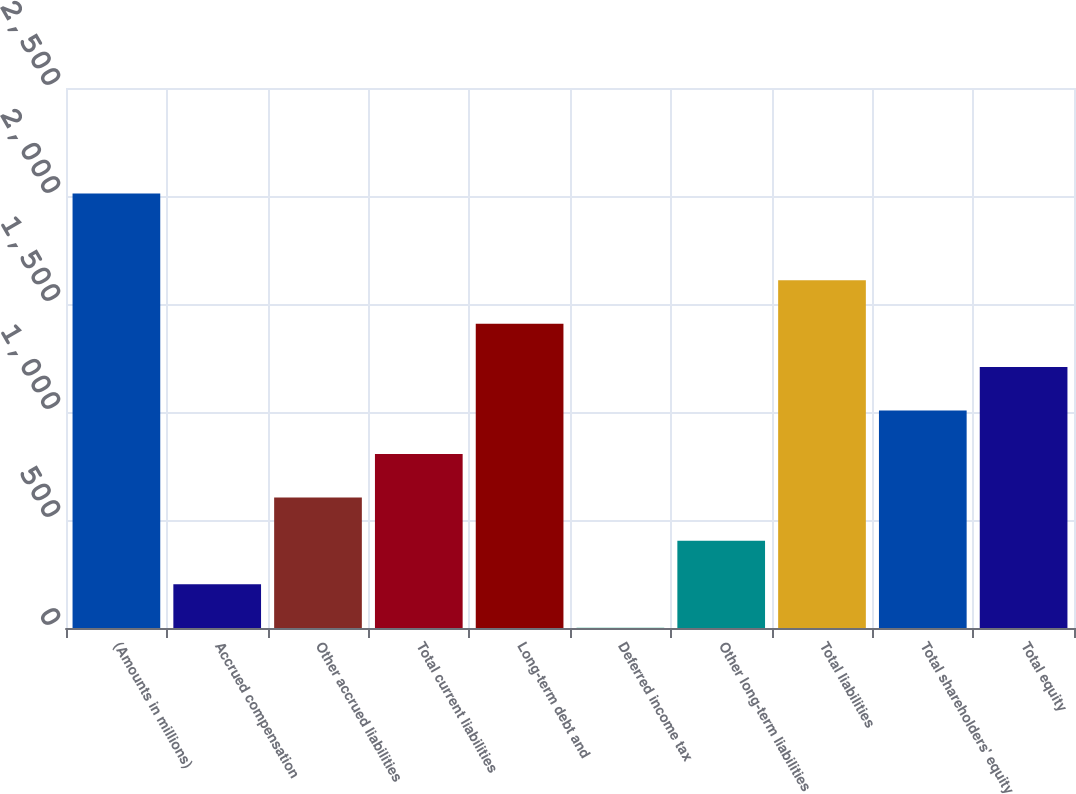Convert chart to OTSL. <chart><loc_0><loc_0><loc_500><loc_500><bar_chart><fcel>(Amounts in millions)<fcel>Accrued compensation<fcel>Other accrued liabilities<fcel>Total current liabilities<fcel>Long-term debt and<fcel>Deferred income tax<fcel>Other long-term liabilities<fcel>Total liabilities<fcel>Total shareholders' equity<fcel>Total equity<nl><fcel>2012<fcel>202.46<fcel>604.58<fcel>805.64<fcel>1408.82<fcel>1.4<fcel>403.52<fcel>1609.88<fcel>1006.7<fcel>1207.76<nl></chart> 